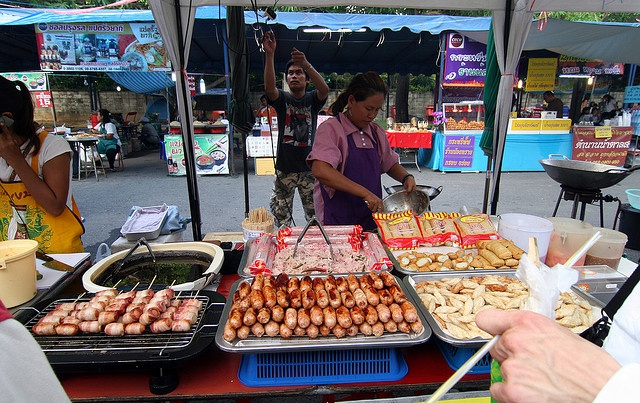Describe the objects in this image and their specific colors. I can see hot dog in gray, black, tan, and maroon tones, people in gray, lightgray, tan, lightpink, and salmon tones, people in gray, black, maroon, olive, and darkgray tones, people in gray, black, maroon, and brown tones, and people in gray, black, and maroon tones in this image. 